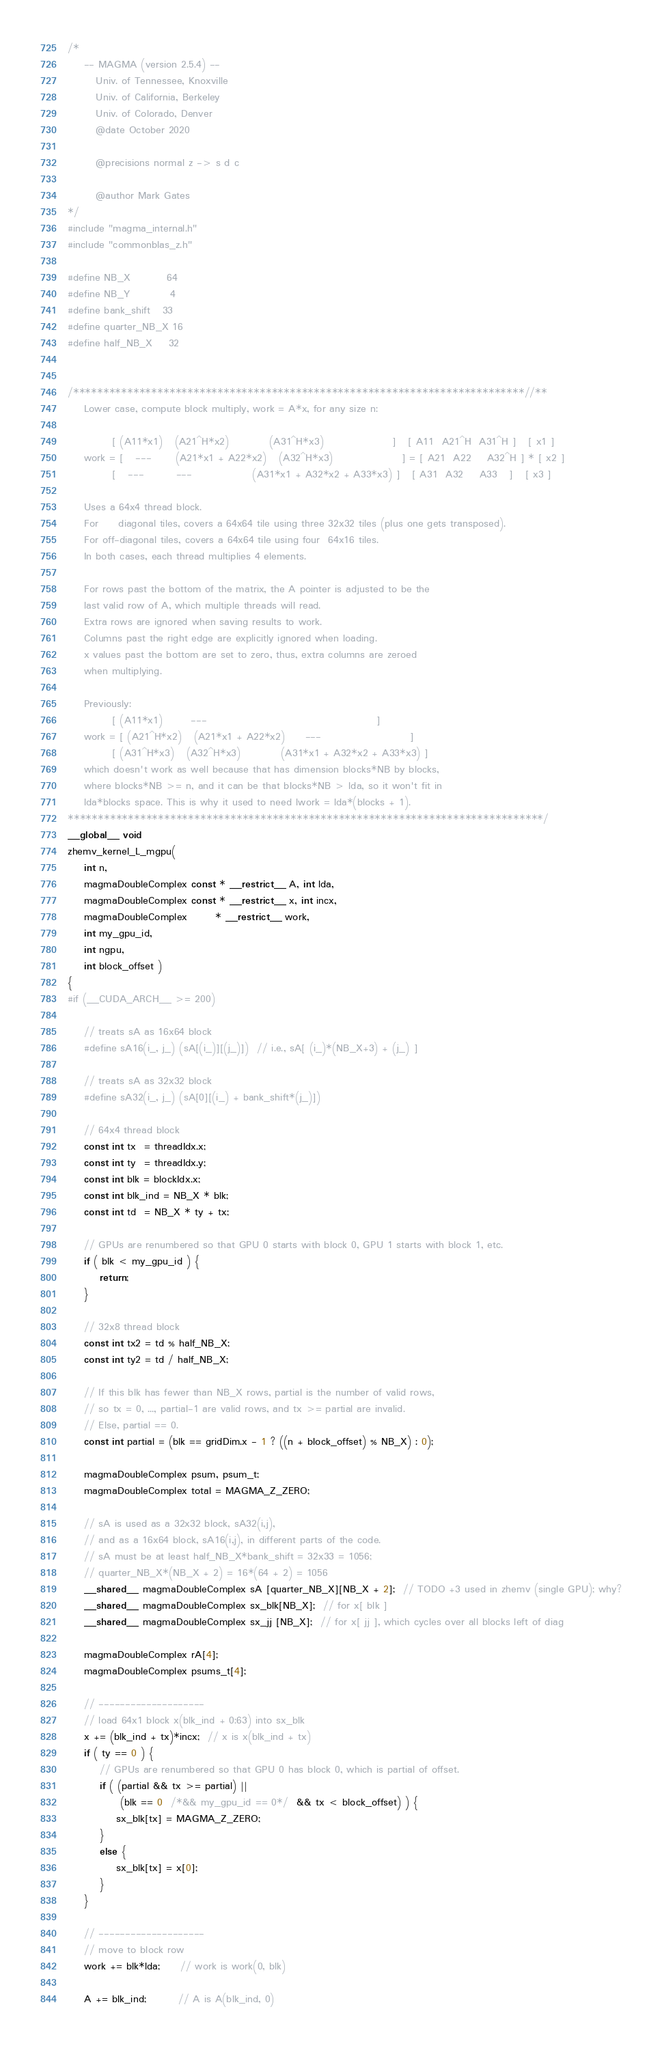Convert code to text. <code><loc_0><loc_0><loc_500><loc_500><_Cuda_>/*
    -- MAGMA (version 2.5.4) --
       Univ. of Tennessee, Knoxville
       Univ. of California, Berkeley
       Univ. of Colorado, Denver
       @date October 2020

       @precisions normal z -> s d c

       @author Mark Gates
*/
#include "magma_internal.h"
#include "commonblas_z.h"

#define NB_X         64
#define NB_Y          4
#define bank_shift   33
#define quarter_NB_X 16
#define half_NB_X    32


/***************************************************************************//**
    Lower case, compute block multiply, work = A*x, for any size n:
    
           [ (A11*x1)   (A21^H*x2)          (A31^H*x3)                 ]   [ A11  A21^H  A31^H ]   [ x1 ]
    work = [   ---      (A21*x1 + A22*x2)   (A32^H*x3)                 ] = [ A21  A22    A32^H ] * [ x2 ]
           [   ---        ---               (A31*x1 + A32*x2 + A33*x3) ]   [ A31  A32    A33   ]   [ x3 ]
    
    Uses a 64x4 thread block.
    For     diagonal tiles, covers a 64x64 tile using three 32x32 tiles (plus one gets transposed).
    For off-diagonal tiles, covers a 64x64 tile using four  64x16 tiles.
    In both cases, each thread multiplies 4 elements.
    
    For rows past the bottom of the matrix, the A pointer is adjusted to be the
    last valid row of A, which multiple threads will read.
    Extra rows are ignored when saving results to work.
    Columns past the right edge are explicitly ignored when loading.
    x values past the bottom are set to zero, thus, extra columns are zeroed
    when multiplying.
    
    Previously:
           [ (A11*x1)       ---                                          ]
    work = [ (A21^H*x2)   (A21*x1 + A22*x2)     ---                      ]
           [ (A31^H*x3)   (A32^H*x3)          (A31*x1 + A32*x2 + A33*x3) ]
    which doesn't work as well because that has dimension blocks*NB by blocks,
    where blocks*NB >= n, and it can be that blocks*NB > lda, so it won't fit in
    lda*blocks space. This is why it used to need lwork = lda*(blocks + 1).
*******************************************************************************/
__global__ void
zhemv_kernel_L_mgpu(
    int n,
    magmaDoubleComplex const * __restrict__ A, int lda,
    magmaDoubleComplex const * __restrict__ x, int incx,
    magmaDoubleComplex       * __restrict__ work,
    int my_gpu_id,
    int ngpu,
    int block_offset )
{
#if (__CUDA_ARCH__ >= 200)

    // treats sA as 16x64 block
    #define sA16(i_, j_) (sA[(i_)][(j_)])  // i.e., sA[ (i_)*(NB_X+3) + (j_) ]
    
    // treats sA as 32x32 block
    #define sA32(i_, j_) (sA[0][(i_) + bank_shift*(j_)])
    
    // 64x4 thread block
    const int tx  = threadIdx.x;
    const int ty  = threadIdx.y;
    const int blk = blockIdx.x;
    const int blk_ind = NB_X * blk;
    const int td  = NB_X * ty + tx;

    // GPUs are renumbered so that GPU 0 starts with block 0, GPU 1 starts with block 1, etc.
    if ( blk < my_gpu_id ) {
        return;
    }

    // 32x8 thread block
    const int tx2 = td % half_NB_X;
    const int ty2 = td / half_NB_X;

    // If this blk has fewer than NB_X rows, partial is the number of valid rows,
    // so tx = 0, ..., partial-1 are valid rows, and tx >= partial are invalid.
    // Else, partial == 0.
    const int partial = (blk == gridDim.x - 1 ? ((n + block_offset) % NB_X) : 0);
    
    magmaDoubleComplex psum, psum_t;
    magmaDoubleComplex total = MAGMA_Z_ZERO;

    // sA is used as a 32x32 block, sA32(i,j),
    // and as a 16x64 block, sA16(i,j), in different parts of the code.
    // sA must be at least half_NB_X*bank_shift = 32x33 = 1056;
    // quarter_NB_X*(NB_X + 2) = 16*(64 + 2) = 1056
    __shared__ magmaDoubleComplex sA [quarter_NB_X][NB_X + 2];  // TODO +3 used in zhemv (single GPU); why?
    __shared__ magmaDoubleComplex sx_blk[NB_X];  // for x[ blk ]
    __shared__ magmaDoubleComplex sx_jj [NB_X];  // for x[ jj ], which cycles over all blocks left of diag

    magmaDoubleComplex rA[4];
    magmaDoubleComplex psums_t[4];

    // --------------------
    // load 64x1 block x(blk_ind + 0:63) into sx_blk
    x += (blk_ind + tx)*incx;  // x is x(blk_ind + tx)
    if ( ty == 0 ) {
        // GPUs are renumbered so that GPU 0 has block 0, which is partial of offset.
        if ( (partial && tx >= partial) ||
             (blk == 0  /*&& my_gpu_id == 0*/  && tx < block_offset) ) {
            sx_blk[tx] = MAGMA_Z_ZERO;
        }
        else {
            sx_blk[tx] = x[0];
        }
    }

    // --------------------
    // move to block row
    work += blk*lda;     // work is work(0, blk)

    A += blk_ind;        // A is A(blk_ind, 0)</code> 